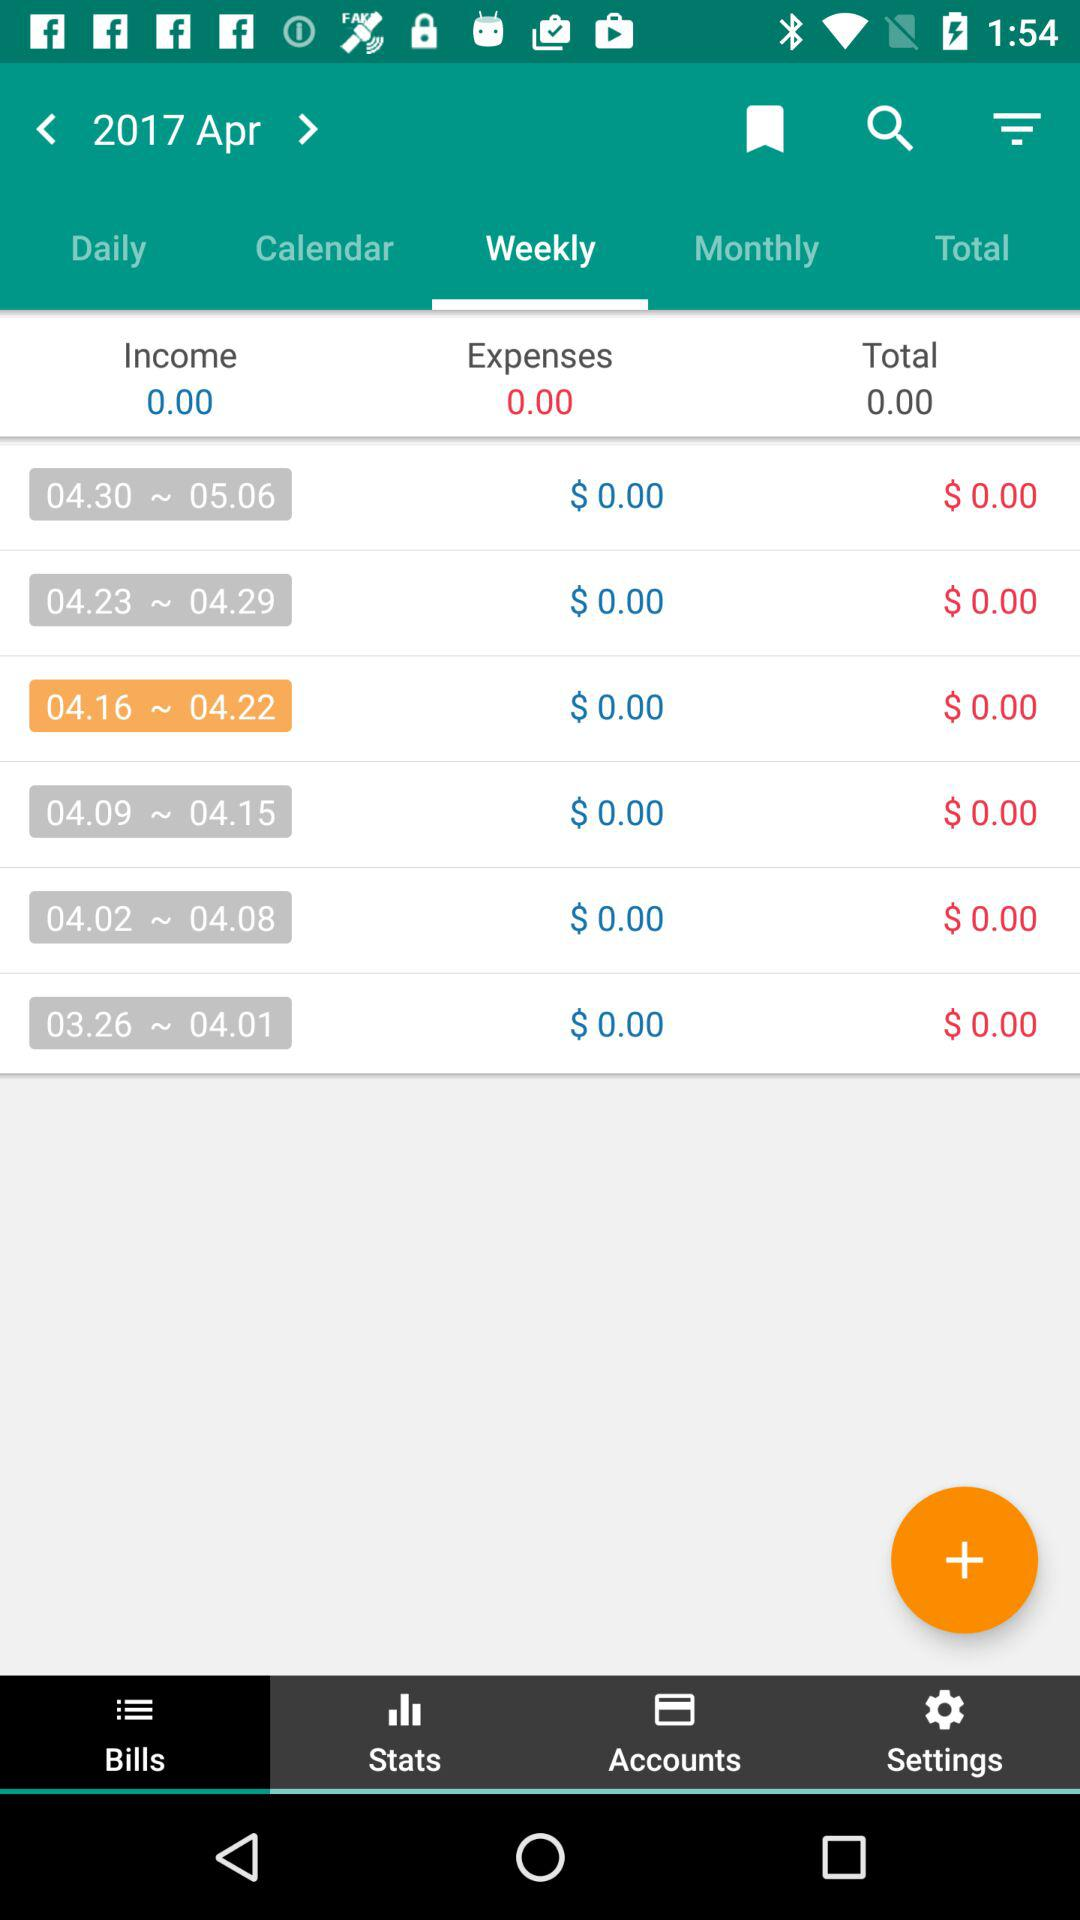How many expenses are shown here? There are 0.00 expenses shown. 